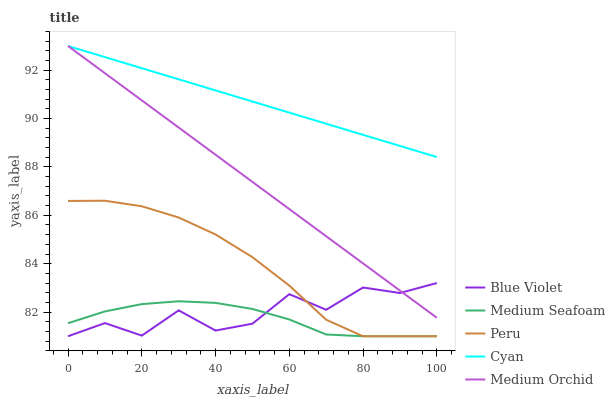Does Medium Seafoam have the minimum area under the curve?
Answer yes or no. Yes. Does Cyan have the maximum area under the curve?
Answer yes or no. Yes. Does Medium Orchid have the minimum area under the curve?
Answer yes or no. No. Does Medium Orchid have the maximum area under the curve?
Answer yes or no. No. Is Cyan the smoothest?
Answer yes or no. Yes. Is Blue Violet the roughest?
Answer yes or no. Yes. Is Medium Orchid the smoothest?
Answer yes or no. No. Is Medium Orchid the roughest?
Answer yes or no. No. Does Peru have the lowest value?
Answer yes or no. Yes. Does Medium Orchid have the lowest value?
Answer yes or no. No. Does Cyan have the highest value?
Answer yes or no. Yes. Does Medium Seafoam have the highest value?
Answer yes or no. No. Is Medium Seafoam less than Medium Orchid?
Answer yes or no. Yes. Is Cyan greater than Medium Seafoam?
Answer yes or no. Yes. Does Peru intersect Medium Seafoam?
Answer yes or no. Yes. Is Peru less than Medium Seafoam?
Answer yes or no. No. Is Peru greater than Medium Seafoam?
Answer yes or no. No. Does Medium Seafoam intersect Medium Orchid?
Answer yes or no. No. 